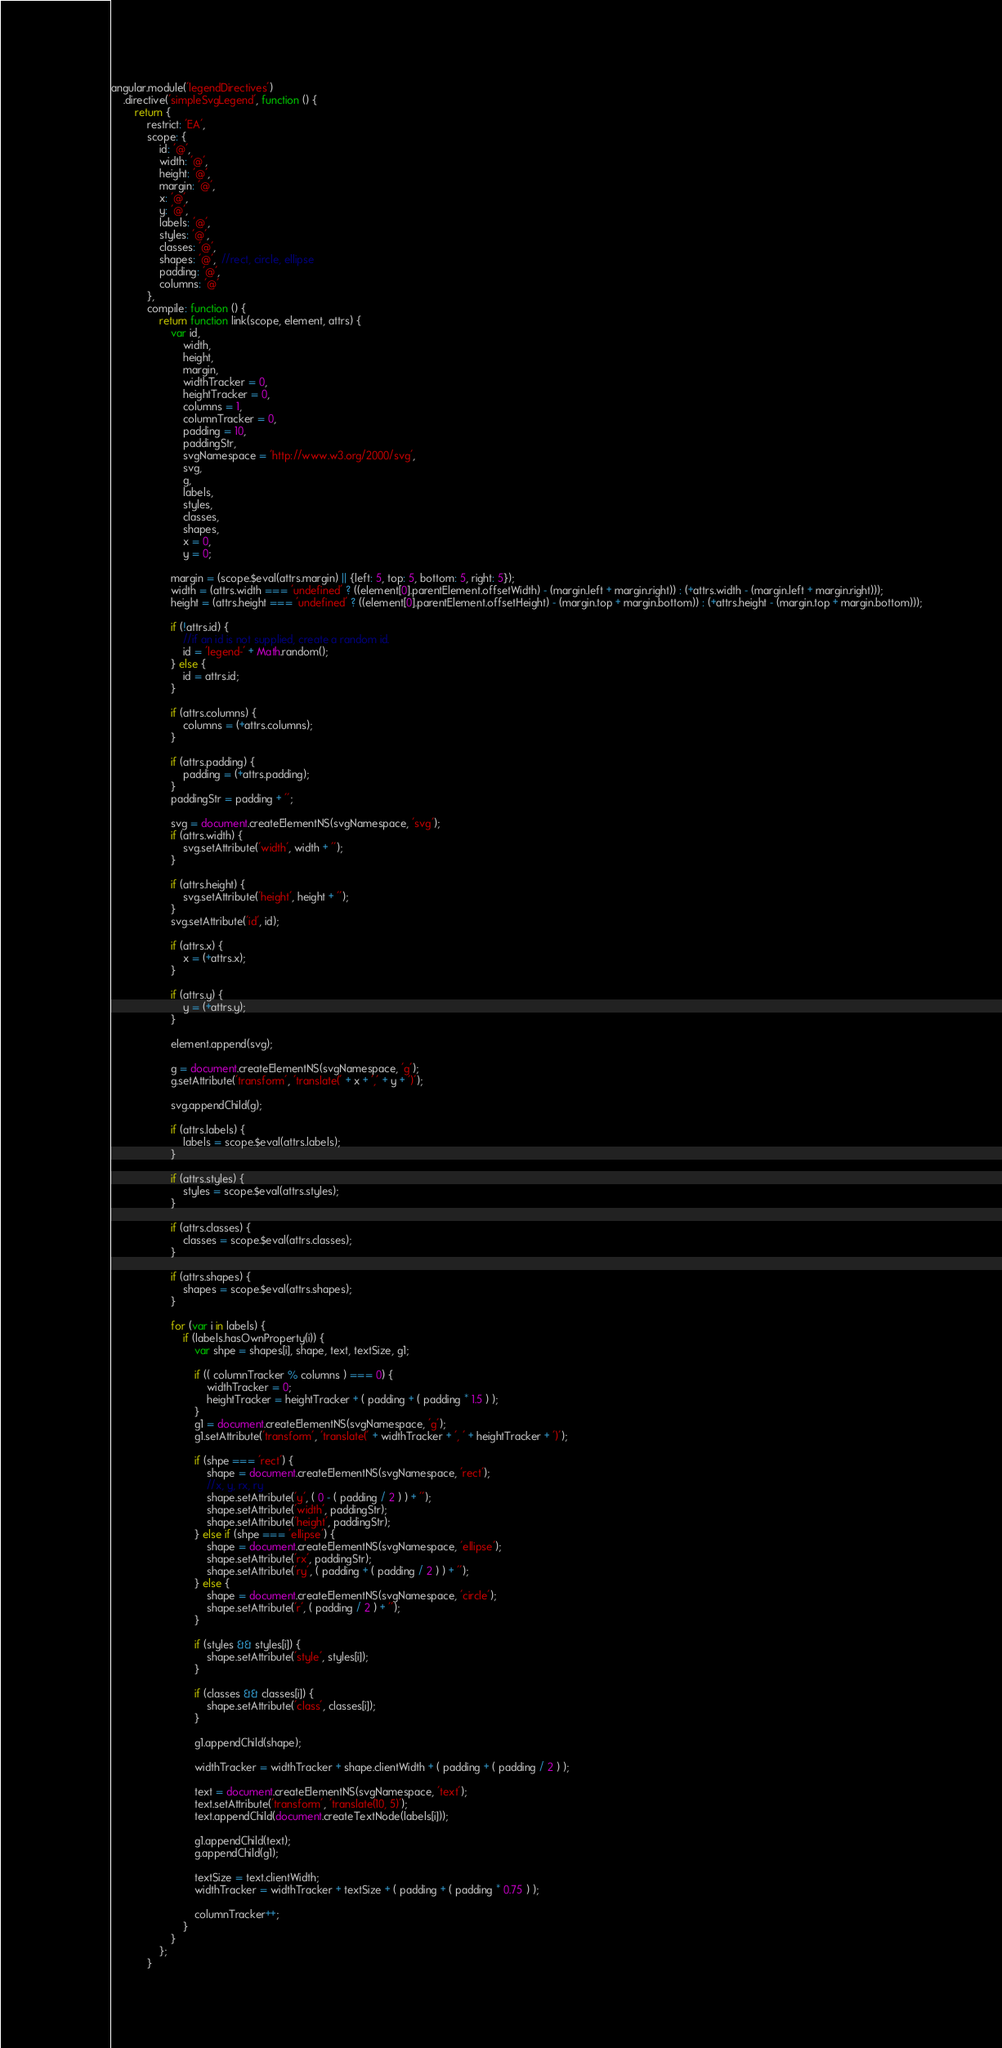<code> <loc_0><loc_0><loc_500><loc_500><_JavaScript_>angular.module('legendDirectives')
	.directive('simpleSvgLegend', function () {
		return {
			restrict: 'EA',
			scope: {
				id: '@',
				width: '@',
				height: '@',
				margin: '@',
				x: '@',
				y: '@',
				labels: '@',
				styles: '@',
				classes: '@',
				shapes: '@',  //rect, circle, ellipse
				padding: '@',
				columns: '@'
			},
			compile: function () {
				return function link(scope, element, attrs) {
					var id,
						width,
						height,
						margin,
						widthTracker = 0,
						heightTracker = 0,
						columns = 1,
						columnTracker = 0,
						padding = 10,
						paddingStr,
						svgNamespace = 'http://www.w3.org/2000/svg',
						svg,
						g,
						labels,
						styles,
						classes,
						shapes,
						x = 0,
						y = 0;

					margin = (scope.$eval(attrs.margin) || {left: 5, top: 5, bottom: 5, right: 5});
					width = (attrs.width === 'undefined' ? ((element[0].parentElement.offsetWidth) - (margin.left + margin.right)) : (+attrs.width - (margin.left + margin.right)));
					height = (attrs.height === 'undefined' ? ((element[0].parentElement.offsetHeight) - (margin.top + margin.bottom)) : (+attrs.height - (margin.top + margin.bottom)));

					if (!attrs.id) {
						//if an id is not supplied, create a random id.
						id = 'legend-' + Math.random();
					} else {
						id = attrs.id;
					}

					if (attrs.columns) {
						columns = (+attrs.columns);
					}

					if (attrs.padding) {
						padding = (+attrs.padding);
					}
					paddingStr = padding + '';

					svg = document.createElementNS(svgNamespace, 'svg');
					if (attrs.width) {
						svg.setAttribute('width', width + '');
					}

					if (attrs.height) {
						svg.setAttribute('height', height + '');
					}
					svg.setAttribute('id', id);

					if (attrs.x) {
						x = (+attrs.x);
					}

					if (attrs.y) {
						y = (+attrs.y);
					}

					element.append(svg);

					g = document.createElementNS(svgNamespace, 'g');
					g.setAttribute('transform', 'translate(' + x + ',' + y + ')');

					svg.appendChild(g);

					if (attrs.labels) {
						labels = scope.$eval(attrs.labels);
					}

					if (attrs.styles) {
						styles = scope.$eval(attrs.styles);
					}

					if (attrs.classes) {
						classes = scope.$eval(attrs.classes);
					}

					if (attrs.shapes) {
						shapes = scope.$eval(attrs.shapes);
					}

					for (var i in labels) {
						if (labels.hasOwnProperty(i)) {
							var shpe = shapes[i], shape, text, textSize, g1;

							if (( columnTracker % columns ) === 0) {
								widthTracker = 0;
								heightTracker = heightTracker + ( padding + ( padding * 1.5 ) );
							}
							g1 = document.createElementNS(svgNamespace, 'g');
							g1.setAttribute('transform', 'translate(' + widthTracker + ', ' + heightTracker + ')');

							if (shpe === 'rect') {
								shape = document.createElementNS(svgNamespace, 'rect');
								//x, y, rx, ry
								shape.setAttribute('y', ( 0 - ( padding / 2 ) ) + '');
								shape.setAttribute('width', paddingStr);
								shape.setAttribute('height', paddingStr);
							} else if (shpe === 'ellipse') {
								shape = document.createElementNS(svgNamespace, 'ellipse');
								shape.setAttribute('rx', paddingStr);
								shape.setAttribute('ry', ( padding + ( padding / 2 ) ) + '');
							} else {
								shape = document.createElementNS(svgNamespace, 'circle');
								shape.setAttribute('r', ( padding / 2 ) + '');
							}

							if (styles && styles[i]) {
								shape.setAttribute('style', styles[i]);
							}

							if (classes && classes[i]) {
								shape.setAttribute('class', classes[i]);
							}

							g1.appendChild(shape);

							widthTracker = widthTracker + shape.clientWidth + ( padding + ( padding / 2 ) );

							text = document.createElementNS(svgNamespace, 'text');
							text.setAttribute('transform', 'translate(10, 5)');
							text.appendChild(document.createTextNode(labels[i]));

							g1.appendChild(text);
							g.appendChild(g1);

							textSize = text.clientWidth;
							widthTracker = widthTracker + textSize + ( padding + ( padding * 0.75 ) );

							columnTracker++;
						}
					}
				};
			}</code> 